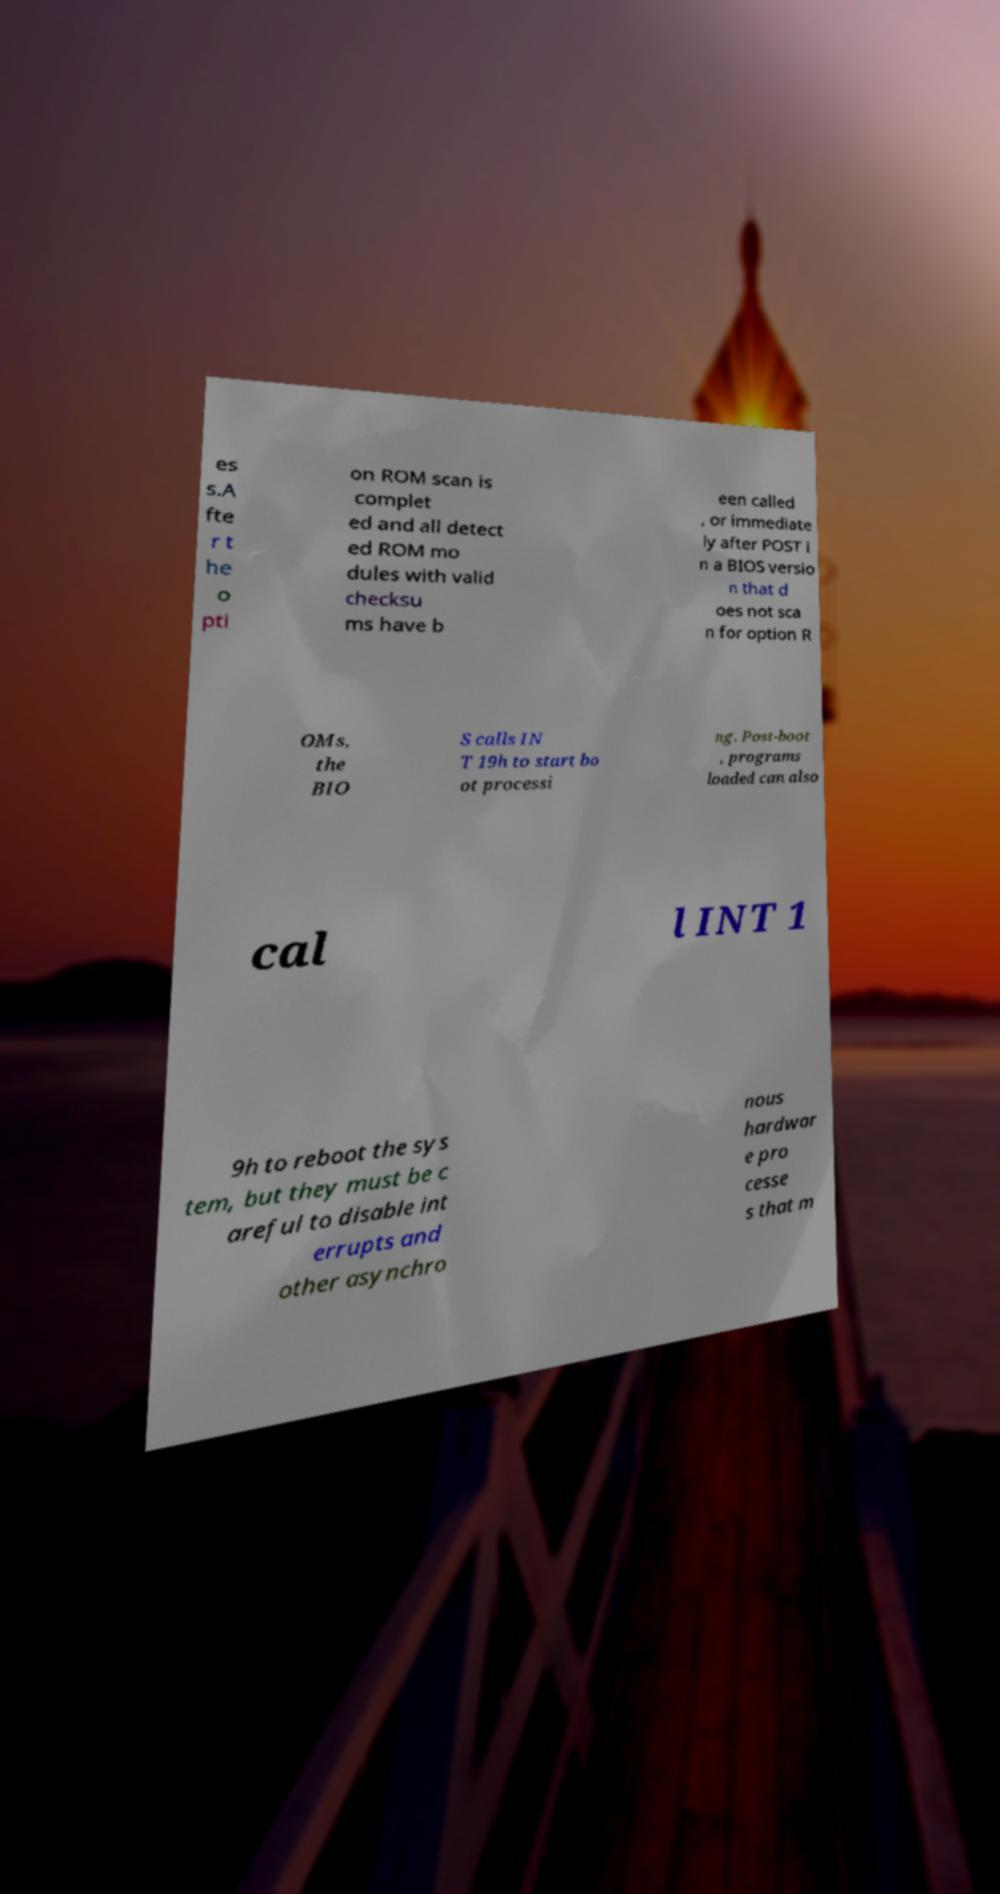For documentation purposes, I need the text within this image transcribed. Could you provide that? es s.A fte r t he o pti on ROM scan is complet ed and all detect ed ROM mo dules with valid checksu ms have b een called , or immediate ly after POST i n a BIOS versio n that d oes not sca n for option R OMs, the BIO S calls IN T 19h to start bo ot processi ng. Post-boot , programs loaded can also cal l INT 1 9h to reboot the sys tem, but they must be c areful to disable int errupts and other asynchro nous hardwar e pro cesse s that m 